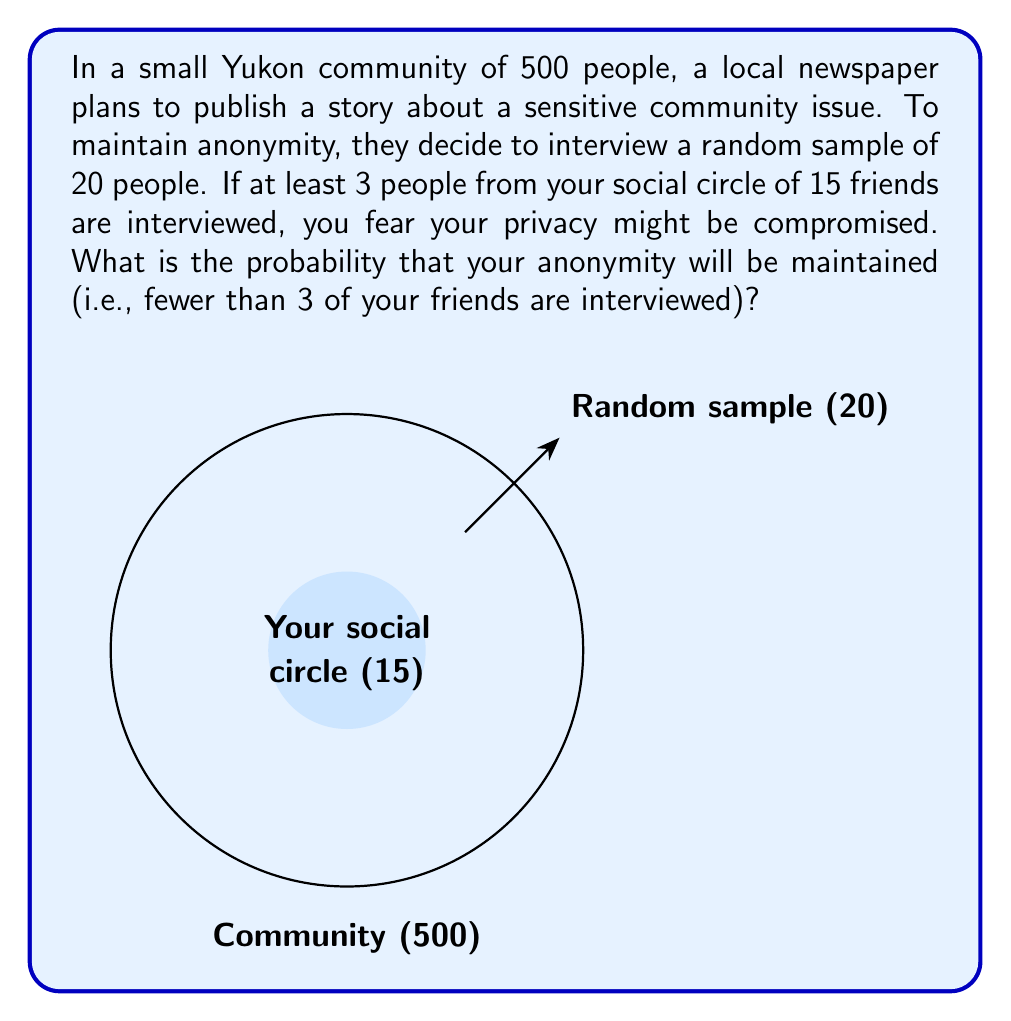Solve this math problem. Let's approach this step-by-step using the hypergeometric distribution:

1) This scenario follows a hypergeometric distribution because:
   - We're sampling without replacement
   - The population (community) size is fixed
   - The sample size is fixed
   - We're interested in the number of successes (friends interviewed)

2) Let X be the number of friends interviewed. We want P(X < 3).

3) The hypergeometric probability mass function is:

   $$P(X = k) = \frac{\binom{K}{k}\binom{N-K}{n-k}}{\binom{N}{n}}$$

   Where:
   N = total population size = 500
   K = number of friends = 15
   n = sample size = 20
   k = number of friends in the sample

4) We need to calculate P(X = 0) + P(X = 1) + P(X = 2):

   $$P(X < 3) = \frac{\binom{15}{0}\binom{485}{20}}{\binom{500}{20}} + \frac{\binom{15}{1}\binom{485}{19}}{\binom{500}{20}} + \frac{\binom{15}{2}\binom{485}{18}}{\binom{500}{20}}$$

5) Calculating each term:

   $$P(X = 0) \approx 0.5424$$
   $$P(X = 1) \approx 0.3477$$
   $$P(X = 2) \approx 0.0946$$

6) Sum these probabilities:

   $$P(X < 3) \approx 0.5424 + 0.3477 + 0.0946 = 0.9847$$

Therefore, the probability of maintaining anonymity is approximately 0.9847 or 98.47%.
Answer: $0.9847$ or $98.47\%$ 